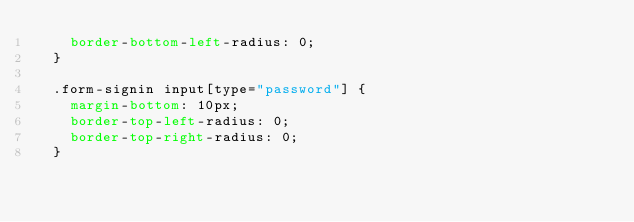Convert code to text. <code><loc_0><loc_0><loc_500><loc_500><_CSS_>    border-bottom-left-radius: 0;
  }
  
  .form-signin input[type="password"] {
    margin-bottom: 10px;
    border-top-left-radius: 0;
    border-top-right-radius: 0;
  }
</code> 